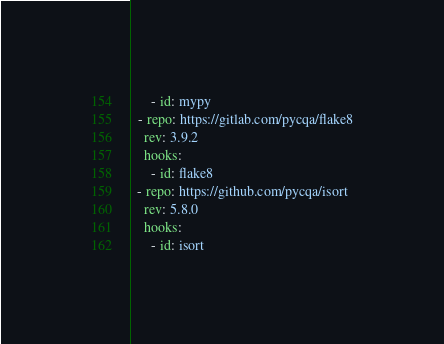<code> <loc_0><loc_0><loc_500><loc_500><_YAML_>      - id: mypy
  - repo: https://gitlab.com/pycqa/flake8
    rev: 3.9.2
    hooks:
      - id: flake8
  - repo: https://github.com/pycqa/isort
    rev: 5.8.0
    hooks:
      - id: isort
</code> 